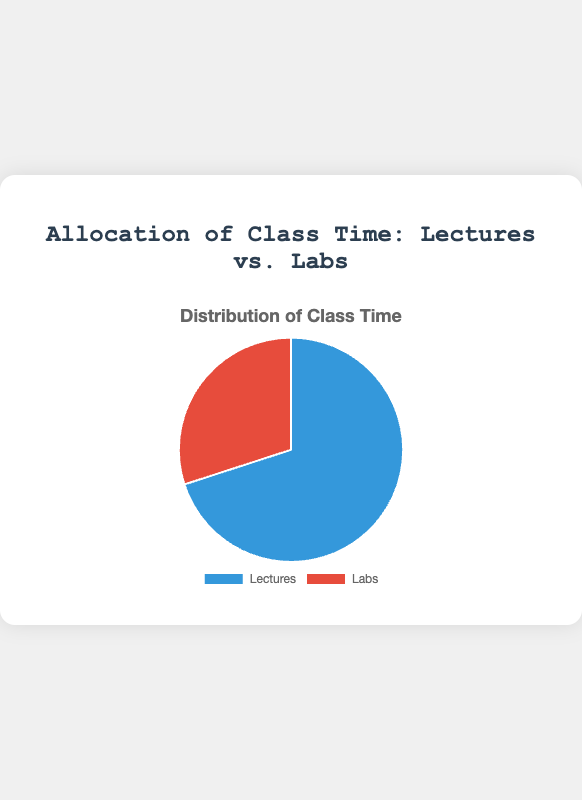What percentage of class time is allocated to lectures? The chart shows the distribution of class time between lectures and labs. The slice labeled "Lectures" represents the portion. According to the chart, it shows that 70% of the class time is allocated to lectures.
Answer: 70% What percentage of class time is allocated to labs? The chart displays the allocation of class time, with labels for each category. The slice labeled "Labs" represents the portion dedicated to labs, which is 30%.
Answer: 30% Which activity takes up more class time, lectures or labs? By looking at the chart, we compare the sizes of the slices. The slice labeled "Lectures" is larger than the one labeled "Labs", indicating that more time is allocated to lectures.
Answer: Lectures What is the ratio of lecture time to lab time? The chart shows 70% allocation for lectures and 30% for labs. To find the ratio, divide 70 by 30, which simplifies to 7:3.
Answer: 7:3 If a class week consists of 10 hours, how much time is allocated to lectures? The chart shows that 70% of the time is for lectures. For a 10-hour week, calculate 70% of 10, which is 0.7 * 10 = 7 hours.
Answer: 7 hours If lectures are reduced by 10%, what percentage of class time would they then represent? The current allocation for lectures is 70%. A 10% reduction means lectures would be 70% * 0.9 = 63%.
Answer: 63% Which color represents the lecture time in the pie chart? The pie chart uses different colors for each segment. The larger segment, representing lectures, is colored blue.
Answer: Blue How much more time is allocated to lectures than to labs? The chart shows 70% for lectures and 30% for labs. The difference is 70% - 30% = 40%.
Answer: 40% Is the allocation of class time more balanced or more skewed towards one activity? By observing the chart, one can see that lecture time (70%) is much larger than lab time (30%), indicating a skew towards lectures rather than a balanced distribution.
Answer: Skewed towards lectures 